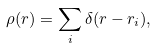<formula> <loc_0><loc_0><loc_500><loc_500>\rho ( r ) = \sum _ { i } \delta ( r - r _ { i } ) ,</formula> 